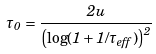<formula> <loc_0><loc_0><loc_500><loc_500>\tau _ { 0 } = \frac { 2 u } { \left ( \log ( 1 + 1 / \tau _ { e f f } ) \right ) ^ { 2 } }</formula> 